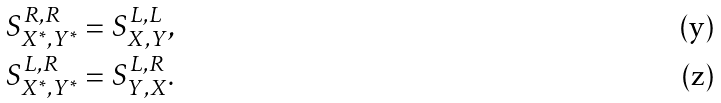Convert formula to latex. <formula><loc_0><loc_0><loc_500><loc_500>S _ { X ^ { * } , Y ^ { * } } ^ { R , R } & = S _ { X , Y } ^ { L , L } , \\ S _ { X ^ { * } , Y ^ { * } } ^ { L , R } & = S _ { Y , X } ^ { L , R } .</formula> 